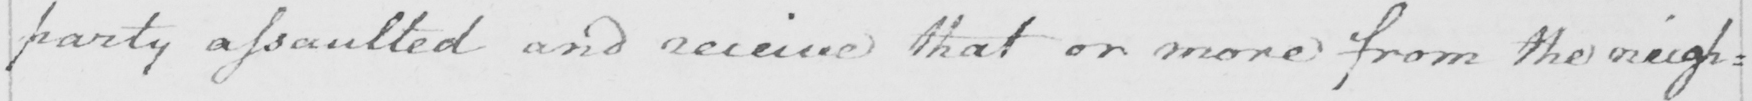What is written in this line of handwriting? party assaulted and receive that or more from the neigh : 